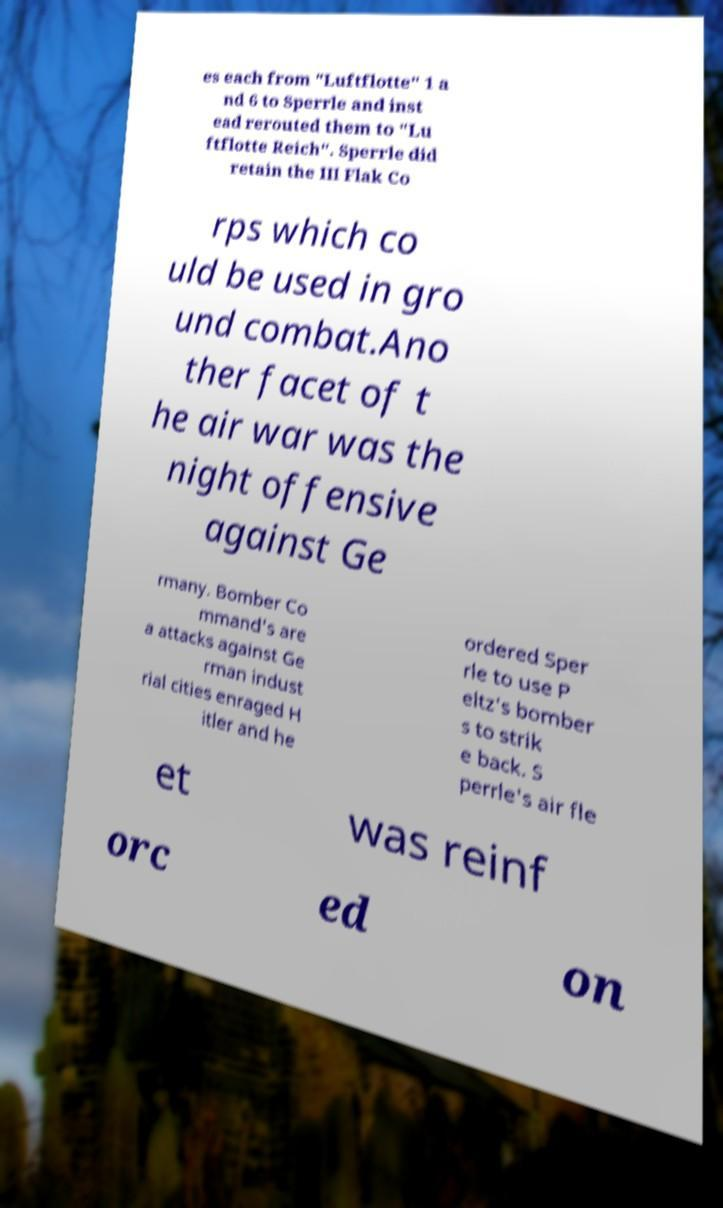There's text embedded in this image that I need extracted. Can you transcribe it verbatim? es each from "Luftflotte" 1 a nd 6 to Sperrle and inst ead rerouted them to "Lu ftflotte Reich". Sperrle did retain the III Flak Co rps which co uld be used in gro und combat.Ano ther facet of t he air war was the night offensive against Ge rmany. Bomber Co mmand's are a attacks against Ge rman indust rial cities enraged H itler and he ordered Sper rle to use P eltz's bomber s to strik e back. S perrle's air fle et was reinf orc ed on 